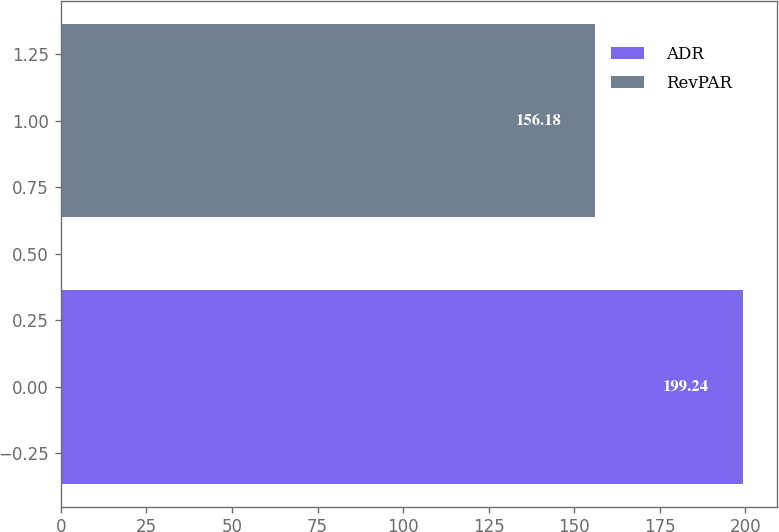<chart> <loc_0><loc_0><loc_500><loc_500><bar_chart><fcel>ADR<fcel>RevPAR<nl><fcel>199.24<fcel>156.18<nl></chart> 